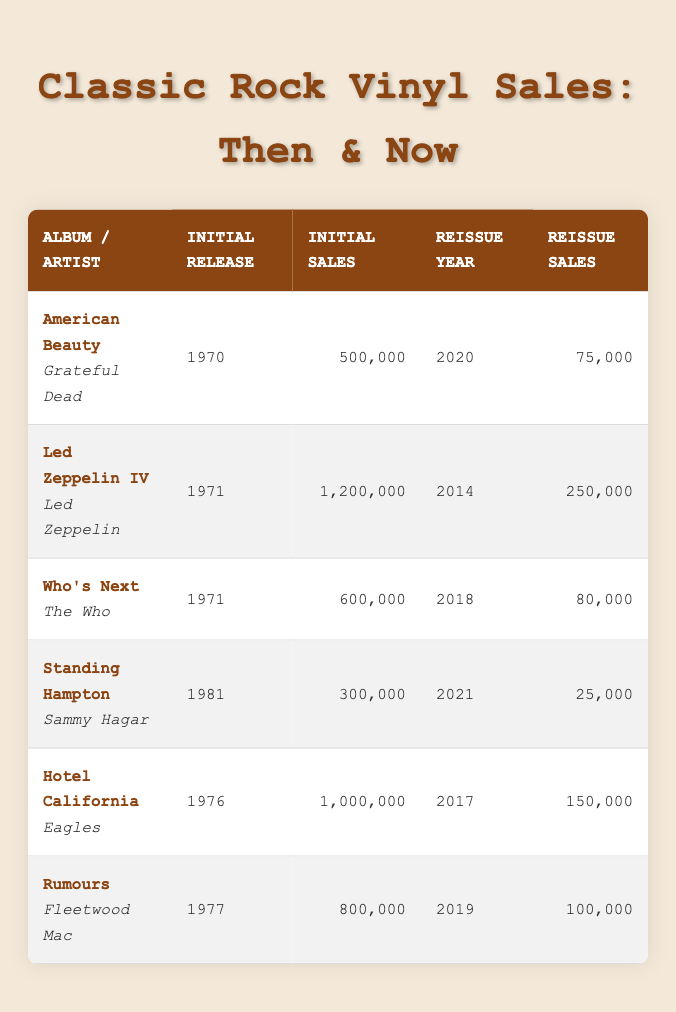What was the initial sales figure for "Hotel California"? The initial sales figure for the album "Hotel California" can be found in the table under the "Initial Sales" column corresponding to its row. The value listed is 1,000,000.
Answer: 1,000,000 Which album had the lowest reissue sales? To find the lowest reissue sales, we look at the "Reissue Sales" column in the table and identify the smallest number. The lowest figure is 25,000, from the album "Standing Hampton."
Answer: 25,000 How many more albums had initial sales over 600,000 compared to those with reissue sales over 100,000? We count the albums with initial sales over 600,000: "Led Zeppelin IV," "Hotel California," and "Rumours," which gives us a total of 3. For reissue sales over 100,000, only "Led Zeppelin IV" and "Hotel California" meet this criterion, totaling 2. Thus, the difference is 3 - 2 = 1.
Answer: 1 Did "American Beauty" have more initial sales than "Standing Hampton"? Comparing the values in the "Initial Sales" column, "American Beauty" has 500,000, and "Standing Hampton" has 300,000. Since 500,000 is greater than 300,000, the answer is yes.
Answer: Yes Which album saw the largest difference between initial sales and reissue sales? To calculate this, we take the difference between initial sales and reissue sales for each album: "American Beauty" (500,000 - 75,000 = 425,000), "Led Zeppelin IV" (1,200,000 - 250,000 = 950,000), "Who's Next" (600,000 - 80,000 = 520,000), "Standing Hampton" (300,000 - 25,000 = 275,000), "Hotel California" (1,000,000 - 150,000 = 850,000), and "Rumours" (800,000 - 100,000 = 700,000). The largest difference is 950,000 for "Led Zeppelin IV."
Answer: Led Zeppelin IV 